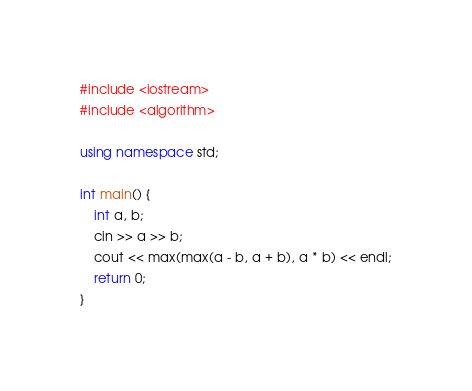Convert code to text. <code><loc_0><loc_0><loc_500><loc_500><_C++_>#include <iostream>
#include <algorithm>

using namespace std;

int main() {
	int a, b;
	cin >> a >> b;
	cout << max(max(a - b, a + b), a * b) << endl;
	return 0;
}</code> 